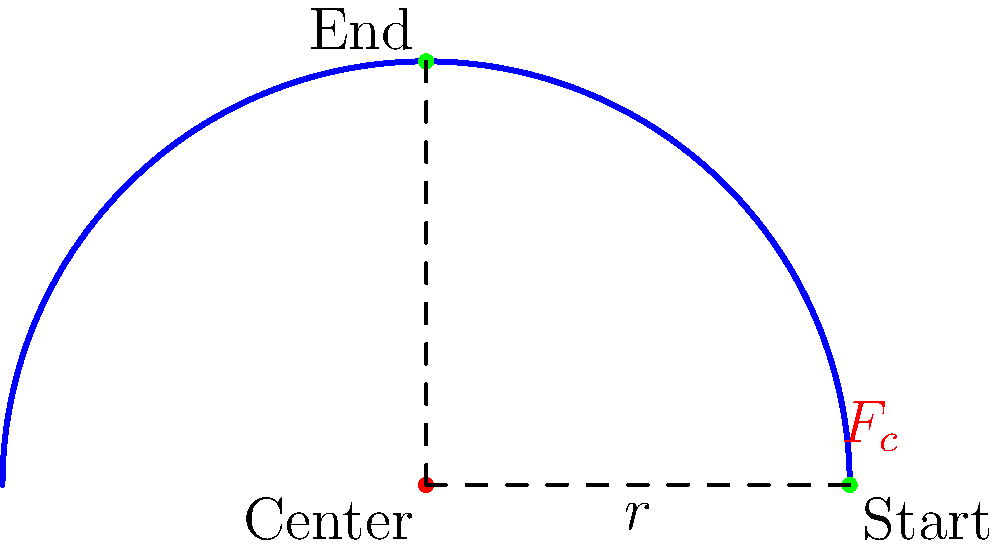In your quest to create a golf-inspired recipe, you're analyzing the physics behind a golfer's swing. Consider a golfer performing a swing with a club head moving in a circular path of radius 1 meter. If the club head has a mass of 0.2 kg and completes half a swing (180°) in 0.5 seconds, what is the magnitude of the centripetal force acting on the club head at the bottom of the swing? Let's approach this step-by-step:

1) First, we need to calculate the angular velocity $\omega$ of the club head.
   - The golfer completes half a circle (π radians) in 0.5 seconds.
   - $\omega = \frac{\text{angle}}{\text{time}} = \frac{\pi \text{ rad}}{0.5 \text{ s}} = 2\pi \text{ rad/s}$

2) Now, we can calculate the linear velocity $v$ of the club head at the bottom of the swing.
   - $v = r\omega$, where $r$ is the radius of the circular path
   - $v = 1 \text{ m} \times 2\pi \text{ rad/s} = 2\pi \text{ m/s}$

3) The centripetal force is given by the formula: $F_c = \frac{mv^2}{r}$
   where $m$ is the mass of the club head, $v$ is its velocity, and $r$ is the radius of the circular path.

4) Let's substitute our values:
   $F_c = \frac{0.2 \text{ kg} \times (2\pi \text{ m/s})^2}{1 \text{ m}}$

5) Simplify:
   $F_c = 0.2 \times 4\pi^2 \text{ N} = 0.8\pi^2 \text{ N} \approx 7.90 \text{ N}$

Therefore, the magnitude of the centripetal force acting on the club head at the bottom of the swing is approximately 7.90 N.
Answer: 7.90 N 